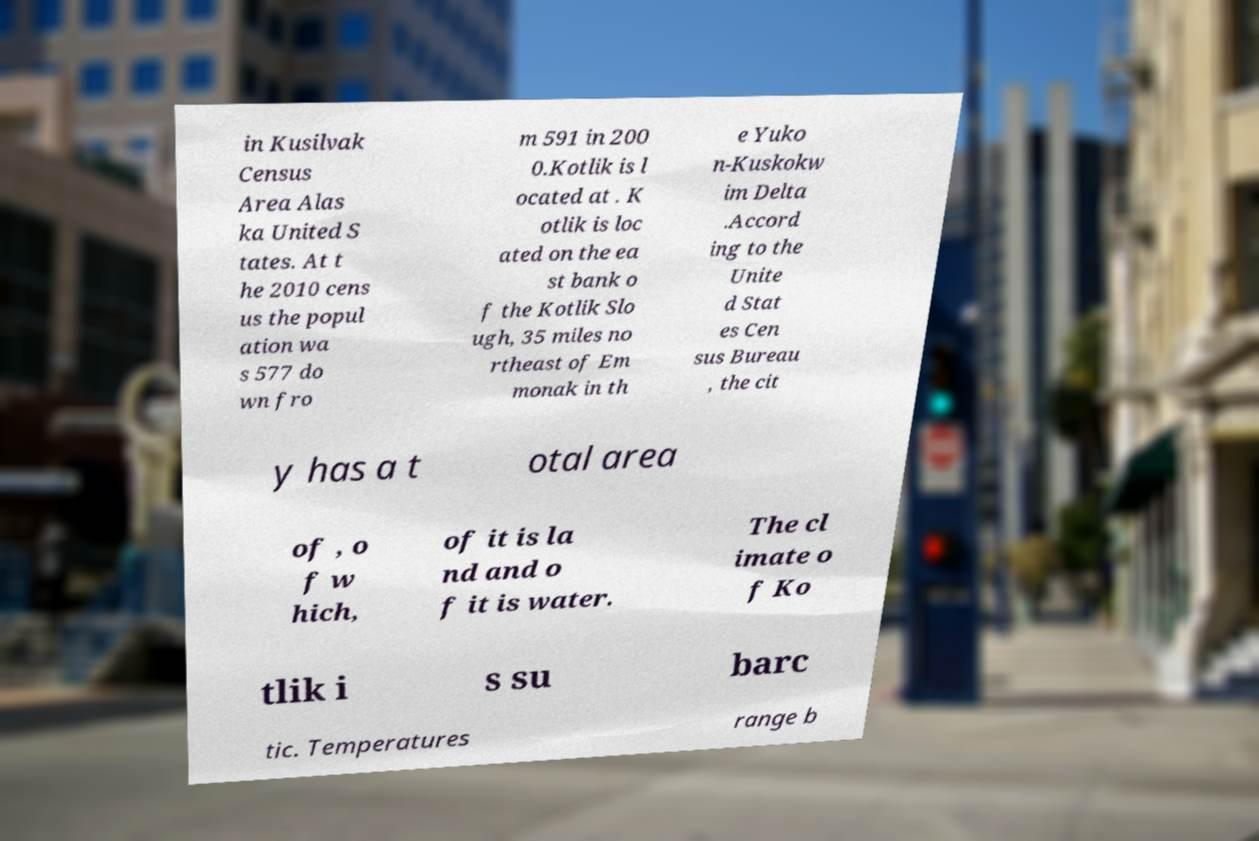Could you extract and type out the text from this image? in Kusilvak Census Area Alas ka United S tates. At t he 2010 cens us the popul ation wa s 577 do wn fro m 591 in 200 0.Kotlik is l ocated at . K otlik is loc ated on the ea st bank o f the Kotlik Slo ugh, 35 miles no rtheast of Em monak in th e Yuko n-Kuskokw im Delta .Accord ing to the Unite d Stat es Cen sus Bureau , the cit y has a t otal area of , o f w hich, of it is la nd and o f it is water. The cl imate o f Ko tlik i s su barc tic. Temperatures range b 